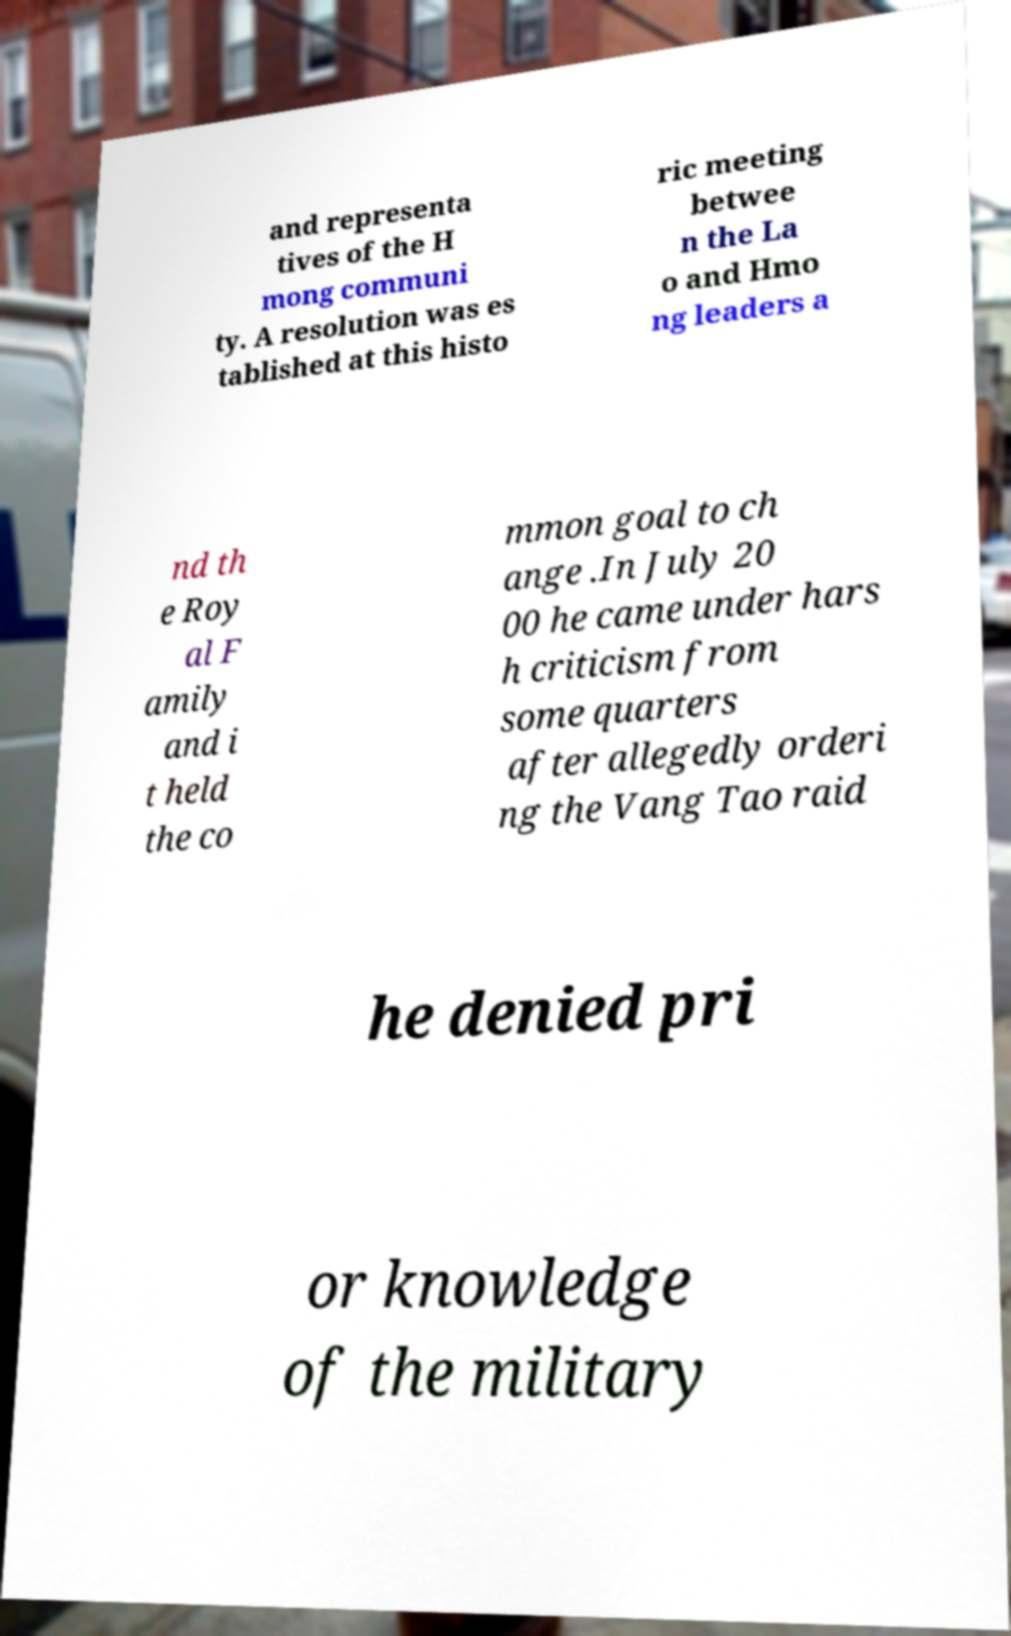Please identify and transcribe the text found in this image. and representa tives of the H mong communi ty. A resolution was es tablished at this histo ric meeting betwee n the La o and Hmo ng leaders a nd th e Roy al F amily and i t held the co mmon goal to ch ange .In July 20 00 he came under hars h criticism from some quarters after allegedly orderi ng the Vang Tao raid he denied pri or knowledge of the military 